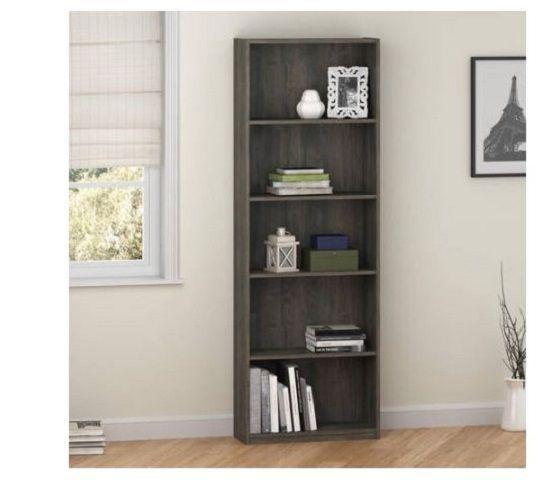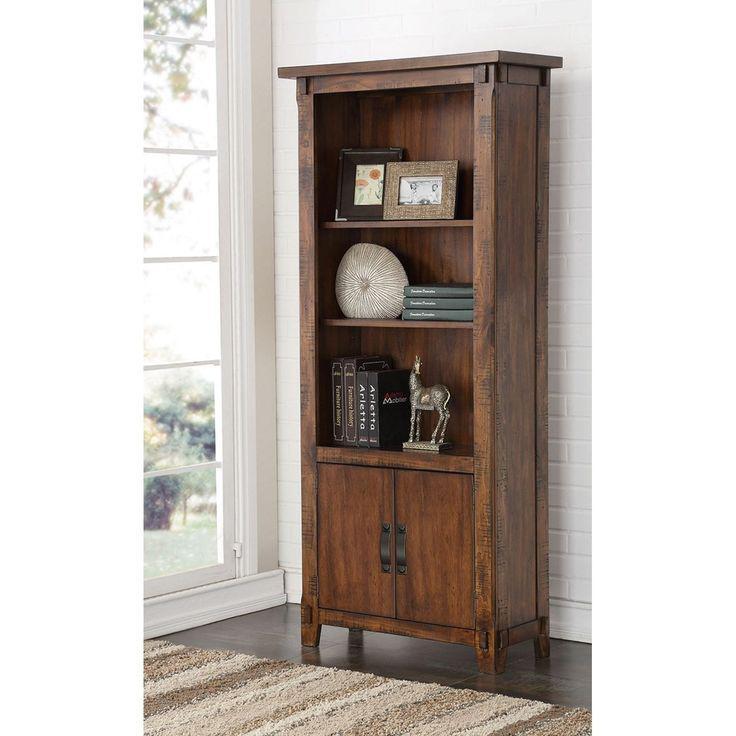The first image is the image on the left, the second image is the image on the right. For the images shown, is this caption "At least one tall, narrow bookcase has closed double doors at the bottom." true? Answer yes or no. Yes. 